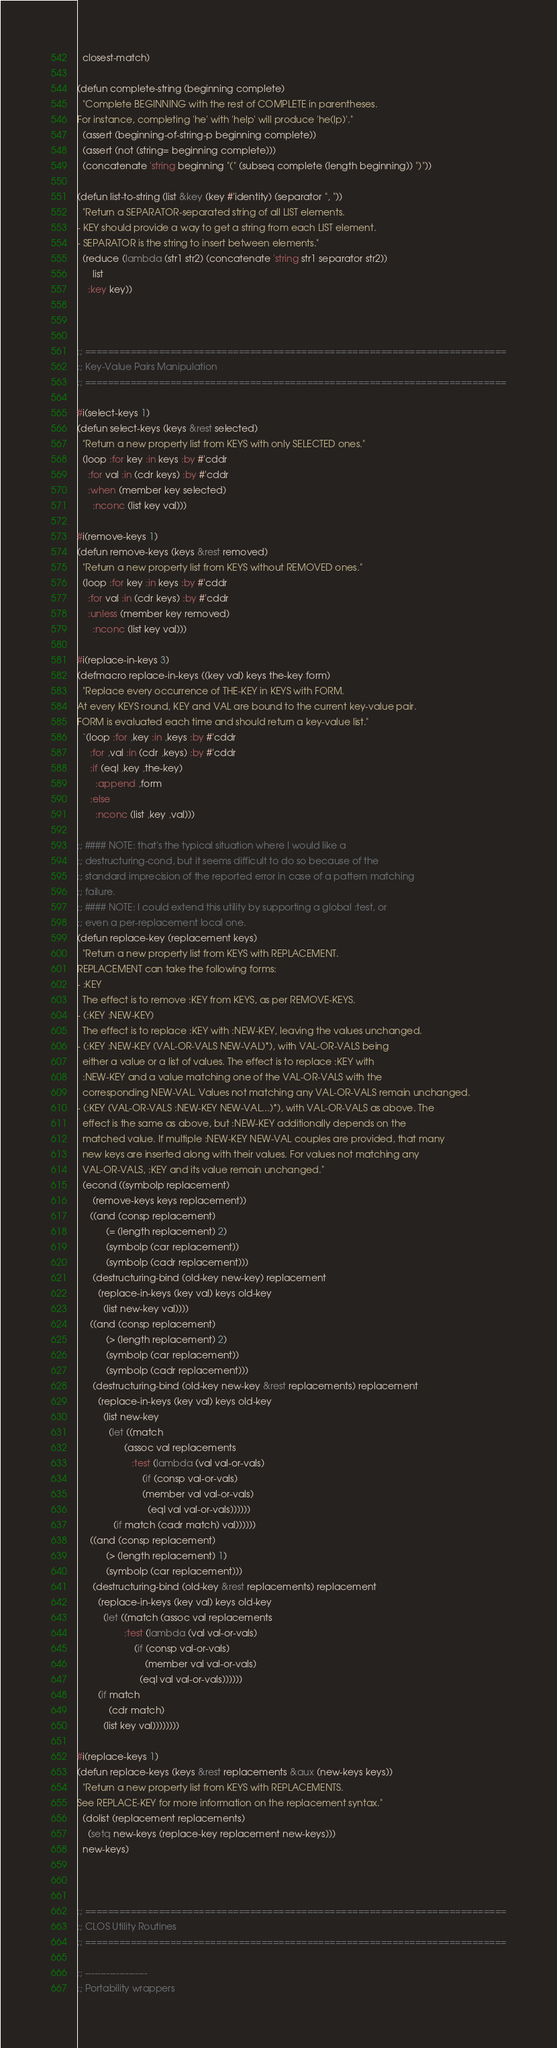Convert code to text. <code><loc_0><loc_0><loc_500><loc_500><_Lisp_>  closest-match)

(defun complete-string (beginning complete)
  "Complete BEGINNING with the rest of COMPLETE in parentheses.
For instance, completing 'he' with 'help' will produce 'he(lp)'."
  (assert (beginning-of-string-p beginning complete))
  (assert (not (string= beginning complete)))
  (concatenate 'string beginning "(" (subseq complete (length beginning)) ")"))

(defun list-to-string (list &key (key #'identity) (separator ", "))
  "Return a SEPARATOR-separated string of all LIST elements.
- KEY should provide a way to get a string from each LIST element.
- SEPARATOR is the string to insert between elements."
  (reduce (lambda (str1 str2) (concatenate 'string str1 separator str2))
      list
    :key key))



;; ==========================================================================
;; Key-Value Pairs Manipulation
;; ==========================================================================

#i(select-keys 1)
(defun select-keys (keys &rest selected)
  "Return a new property list from KEYS with only SELECTED ones."
  (loop :for key :in keys :by #'cddr
	:for val :in (cdr keys) :by #'cddr
	:when (member key selected)
	  :nconc (list key val)))

#i(remove-keys 1)
(defun remove-keys (keys &rest removed)
  "Return a new property list from KEYS without REMOVED ones."
  (loop :for key :in keys :by #'cddr
	:for val :in (cdr keys) :by #'cddr
	:unless (member key removed)
	  :nconc (list key val)))

#i(replace-in-keys 3)
(defmacro replace-in-keys ((key val) keys the-key form)
  "Replace every occurrence of THE-KEY in KEYS with FORM.
At every KEYS round, KEY and VAL are bound to the current key-value pair.
FORM is evaluated each time and should return a key-value list."
  `(loop :for ,key :in ,keys :by #'cddr
	 :for ,val :in (cdr ,keys) :by #'cddr
	 :if (eql ,key ,the-key)
	   :append ,form
	 :else
	   :nconc (list ,key ,val)))

;; #### NOTE: that's the typical situation where I would like a
;; destructuring-cond, but it seems difficult to do so because of the
;; standard imprecision of the reported error in case of a pattern matching
;; failure.
;; #### NOTE: I could extend this utility by supporting a global :test, or
;; even a per-replacement local one.
(defun replace-key (replacement keys)
  "Return a new property list from KEYS with REPLACEMENT.
REPLACEMENT can take the following forms:
- :KEY
  The effect is to remove :KEY from KEYS, as per REMOVE-KEYS.
- (:KEY :NEW-KEY)
  The effect is to replace :KEY with :NEW-KEY, leaving the values unchanged.
- (:KEY :NEW-KEY (VAL-OR-VALS NEW-VAL)*), with VAL-OR-VALS being
  either a value or a list of values. The effect is to replace :KEY with
  :NEW-KEY and a value matching one of the VAL-OR-VALS with the
  corresponding NEW-VAL. Values not matching any VAL-OR-VALS remain unchanged.
- (:KEY (VAL-OR-VALS :NEW-KEY NEW-VAL...)*), with VAL-OR-VALS as above. The
  effect is the same as above, but :NEW-KEY additionally depends on the
  matched value. If multiple :NEW-KEY NEW-VAL couples are provided, that many
  new keys are inserted along with their values. For values not matching any
  VAL-OR-VALS, :KEY and its value remain unchanged."
  (econd ((symbolp replacement)
	  (remove-keys keys replacement))
	 ((and (consp replacement)
	       (= (length replacement) 2)
	       (symbolp (car replacement))
	       (symbolp (cadr replacement)))
	  (destructuring-bind (old-key new-key) replacement
	    (replace-in-keys (key val) keys old-key
	      (list new-key val))))
	 ((and (consp replacement)
	       (> (length replacement) 2)
	       (symbolp (car replacement))
	       (symbolp (cadr replacement)))
	  (destructuring-bind (old-key new-key &rest replacements) replacement
	    (replace-in-keys (key val) keys old-key
	      (list new-key
		    (let ((match
			      (assoc val replacements
				     :test (lambda (val val-or-vals)
					     (if (consp val-or-vals)
						 (member val val-or-vals)
					       (eql val val-or-vals))))))
		      (if match (cadr match) val))))))
	 ((and (consp replacement)
	       (> (length replacement) 1)
	       (symbolp (car replacement)))
	  (destructuring-bind (old-key &rest replacements) replacement
	    (replace-in-keys (key val) keys old-key
	      (let ((match (assoc val replacements
				  :test (lambda (val val-or-vals)
					  (if (consp val-or-vals)
					      (member val val-or-vals)
					    (eql val val-or-vals))))))
		(if match
		    (cdr match)
		  (list key val))))))))

#i(replace-keys 1)
(defun replace-keys (keys &rest replacements &aux (new-keys keys))
  "Return a new property list from KEYS with REPLACEMENTS.
See REPLACE-KEY for more information on the replacement syntax."
  (dolist (replacement replacements)
    (setq new-keys (replace-key replacement new-keys)))
  new-keys)



;; ==========================================================================
;; CLOS Utility Routines
;; ==========================================================================

;; --------------------
;; Portability wrappers</code> 